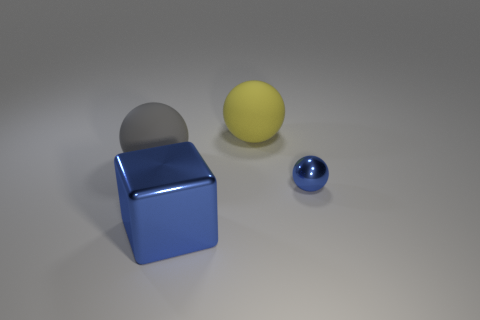Are there any other things that are the same size as the blue metal ball?
Offer a terse response. No. There is a large rubber object to the right of the large sphere in front of the matte thing that is behind the big gray thing; what shape is it?
Give a very brief answer. Sphere. How many other objects are there of the same color as the small ball?
Offer a very short reply. 1. What shape is the big object in front of the ball that is on the right side of the big yellow matte thing?
Your response must be concise. Cube. What number of big blue metallic objects are in front of the gray thing?
Your answer should be very brief. 1. Are there any yellow objects made of the same material as the gray object?
Offer a terse response. Yes. There is a gray sphere that is the same size as the metal cube; what is it made of?
Offer a very short reply. Rubber. There is a object that is left of the big yellow object and in front of the gray rubber sphere; what size is it?
Provide a short and direct response. Large. There is a object that is in front of the gray ball and on the right side of the big blue block; what is its color?
Ensure brevity in your answer.  Blue. Is the number of gray things behind the blue shiny ball less than the number of spheres in front of the yellow rubber object?
Ensure brevity in your answer.  Yes. 